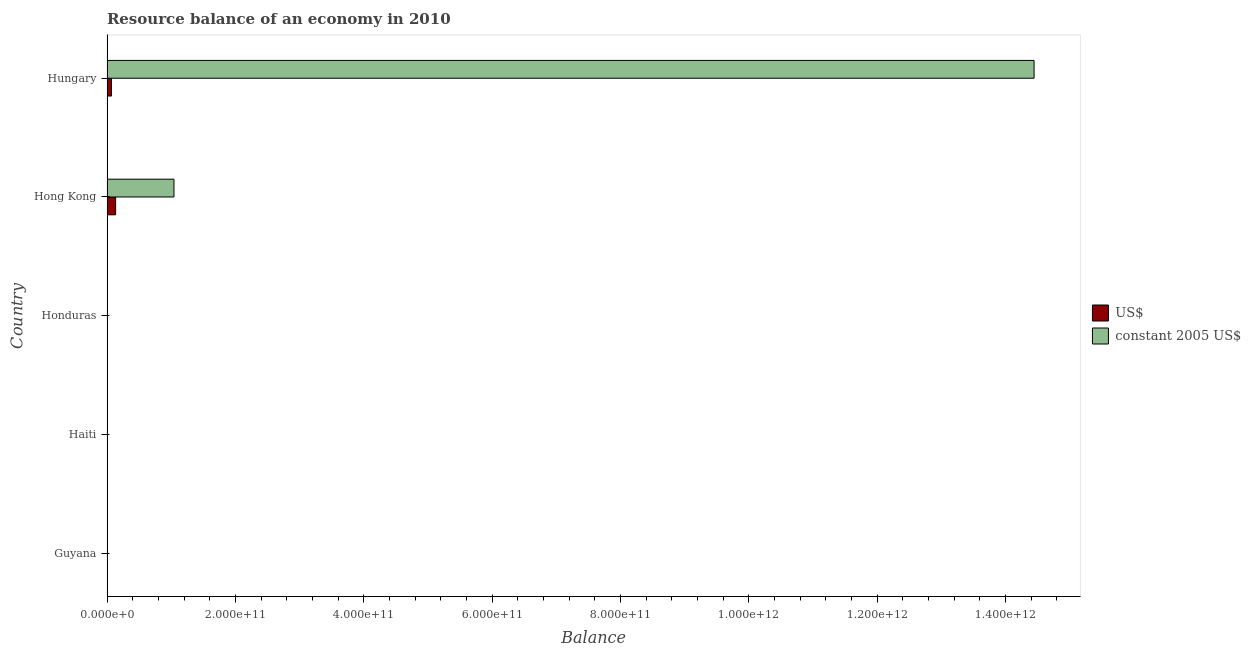How many different coloured bars are there?
Ensure brevity in your answer.  2. Are the number of bars per tick equal to the number of legend labels?
Keep it short and to the point. No. How many bars are there on the 4th tick from the top?
Your answer should be compact. 0. How many bars are there on the 4th tick from the bottom?
Provide a short and direct response. 2. What is the label of the 5th group of bars from the top?
Give a very brief answer. Guyana. In how many cases, is the number of bars for a given country not equal to the number of legend labels?
Offer a very short reply. 3. Across all countries, what is the maximum resource balance in us$?
Offer a terse response. 1.34e+1. In which country was the resource balance in constant us$ maximum?
Provide a succinct answer. Hungary. What is the total resource balance in constant us$ in the graph?
Your answer should be compact. 1.55e+12. What is the difference between the resource balance in us$ in Hong Kong and that in Hungary?
Offer a terse response. 6.48e+09. What is the difference between the resource balance in constant us$ in Hungary and the resource balance in us$ in Guyana?
Your answer should be very brief. 1.44e+12. What is the average resource balance in constant us$ per country?
Your response must be concise. 3.10e+11. What is the difference between the resource balance in constant us$ and resource balance in us$ in Hungary?
Offer a very short reply. 1.44e+12. What is the ratio of the resource balance in us$ in Hong Kong to that in Hungary?
Keep it short and to the point. 1.93. What is the difference between the highest and the lowest resource balance in us$?
Make the answer very short. 1.34e+1. In how many countries, is the resource balance in constant us$ greater than the average resource balance in constant us$ taken over all countries?
Offer a terse response. 1. Is the sum of the resource balance in constant us$ in Hong Kong and Hungary greater than the maximum resource balance in us$ across all countries?
Your answer should be compact. Yes. How many bars are there?
Make the answer very short. 4. What is the difference between two consecutive major ticks on the X-axis?
Your answer should be very brief. 2.00e+11. Are the values on the major ticks of X-axis written in scientific E-notation?
Your answer should be compact. Yes. Does the graph contain grids?
Offer a terse response. No. Where does the legend appear in the graph?
Make the answer very short. Center right. What is the title of the graph?
Make the answer very short. Resource balance of an economy in 2010. What is the label or title of the X-axis?
Provide a short and direct response. Balance. What is the Balance in constant 2005 US$ in Honduras?
Offer a terse response. 0. What is the Balance of US$ in Hong Kong?
Your response must be concise. 1.34e+1. What is the Balance in constant 2005 US$ in Hong Kong?
Keep it short and to the point. 1.04e+11. What is the Balance of US$ in Hungary?
Your response must be concise. 6.95e+09. What is the Balance in constant 2005 US$ in Hungary?
Give a very brief answer. 1.44e+12. Across all countries, what is the maximum Balance in US$?
Your answer should be very brief. 1.34e+1. Across all countries, what is the maximum Balance in constant 2005 US$?
Provide a short and direct response. 1.44e+12. Across all countries, what is the minimum Balance of constant 2005 US$?
Provide a short and direct response. 0. What is the total Balance in US$ in the graph?
Keep it short and to the point. 2.04e+1. What is the total Balance in constant 2005 US$ in the graph?
Your response must be concise. 1.55e+12. What is the difference between the Balance in US$ in Hong Kong and that in Hungary?
Your answer should be compact. 6.48e+09. What is the difference between the Balance of constant 2005 US$ in Hong Kong and that in Hungary?
Make the answer very short. -1.34e+12. What is the difference between the Balance of US$ in Hong Kong and the Balance of constant 2005 US$ in Hungary?
Your answer should be very brief. -1.43e+12. What is the average Balance in US$ per country?
Your answer should be very brief. 4.08e+09. What is the average Balance of constant 2005 US$ per country?
Keep it short and to the point. 3.10e+11. What is the difference between the Balance of US$ and Balance of constant 2005 US$ in Hong Kong?
Offer a terse response. -9.09e+1. What is the difference between the Balance of US$ and Balance of constant 2005 US$ in Hungary?
Give a very brief answer. -1.44e+12. What is the ratio of the Balance of US$ in Hong Kong to that in Hungary?
Offer a very short reply. 1.93. What is the ratio of the Balance in constant 2005 US$ in Hong Kong to that in Hungary?
Provide a succinct answer. 0.07. What is the difference between the highest and the lowest Balance in US$?
Your answer should be very brief. 1.34e+1. What is the difference between the highest and the lowest Balance of constant 2005 US$?
Offer a very short reply. 1.44e+12. 